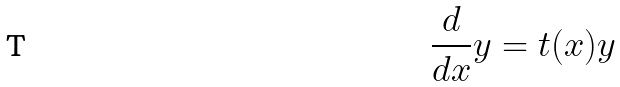Convert formula to latex. <formula><loc_0><loc_0><loc_500><loc_500>\frac { d } { d x } y = t ( x ) y</formula> 